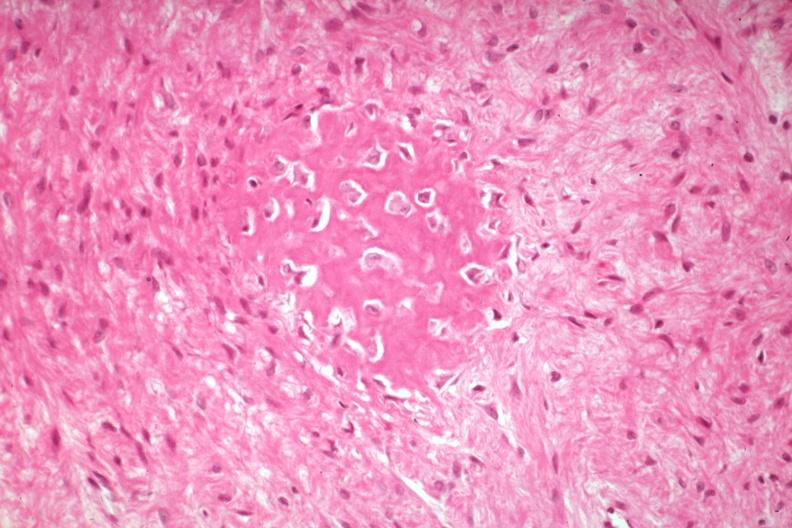what does this image show?
Answer the question using a single word or phrase. High excessive fibrous callus with focal osteoid deposition with osteoblasts 